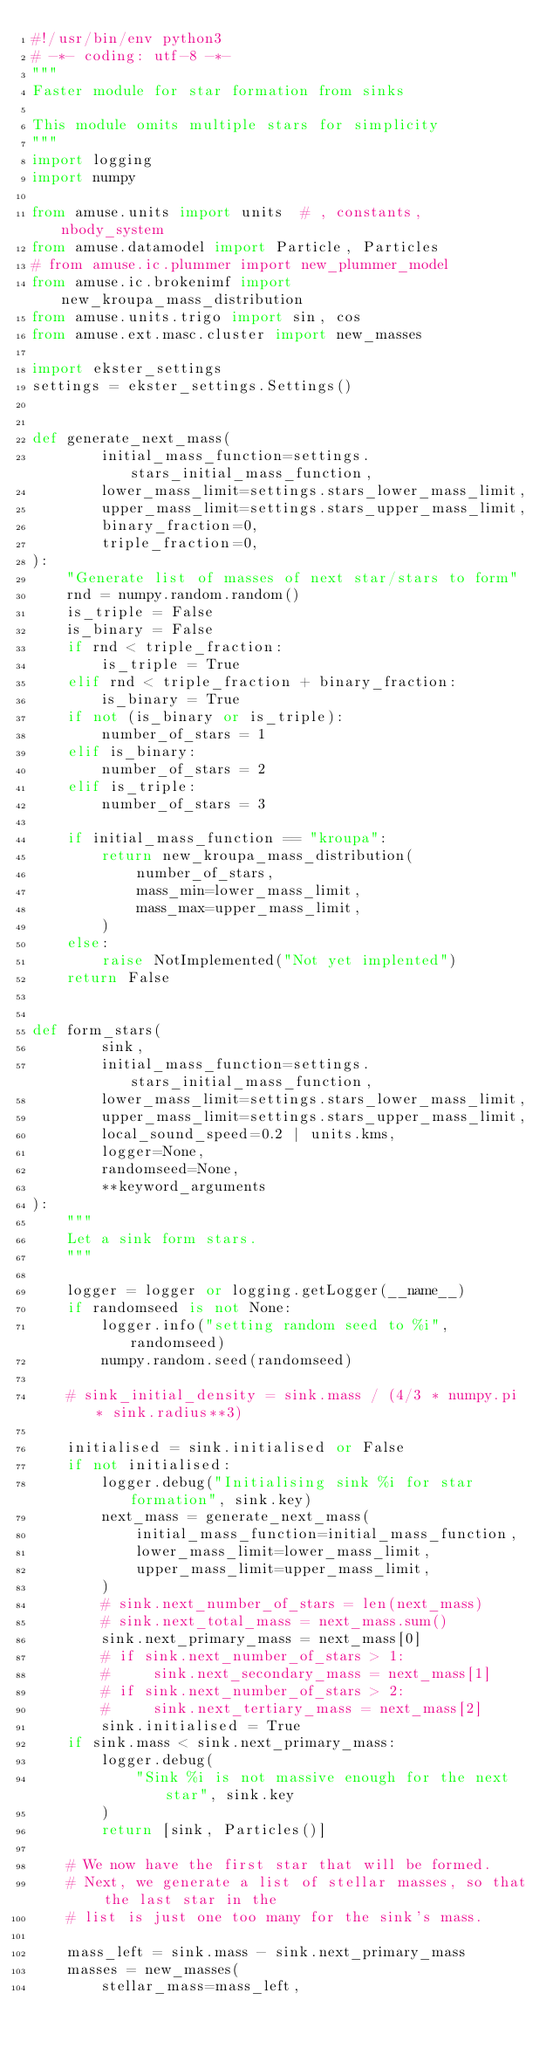<code> <loc_0><loc_0><loc_500><loc_500><_Python_>#!/usr/bin/env python3
# -*- coding: utf-8 -*-
"""
Faster module for star formation from sinks

This module omits multiple stars for simplicity
"""
import logging
import numpy

from amuse.units import units  # , constants, nbody_system
from amuse.datamodel import Particle, Particles
# from amuse.ic.plummer import new_plummer_model
from amuse.ic.brokenimf import new_kroupa_mass_distribution
from amuse.units.trigo import sin, cos
from amuse.ext.masc.cluster import new_masses

import ekster_settings
settings = ekster_settings.Settings()


def generate_next_mass(
        initial_mass_function=settings.stars_initial_mass_function,
        lower_mass_limit=settings.stars_lower_mass_limit,
        upper_mass_limit=settings.stars_upper_mass_limit,
        binary_fraction=0,
        triple_fraction=0,
):
    "Generate list of masses of next star/stars to form"
    rnd = numpy.random.random()
    is_triple = False
    is_binary = False
    if rnd < triple_fraction:
        is_triple = True
    elif rnd < triple_fraction + binary_fraction:
        is_binary = True
    if not (is_binary or is_triple):
        number_of_stars = 1
    elif is_binary:
        number_of_stars = 2
    elif is_triple:
        number_of_stars = 3

    if initial_mass_function == "kroupa":
        return new_kroupa_mass_distribution(
            number_of_stars,
            mass_min=lower_mass_limit,
            mass_max=upper_mass_limit,
        )
    else:
        raise NotImplemented("Not yet implented")
    return False


def form_stars(
        sink,
        initial_mass_function=settings.stars_initial_mass_function,
        lower_mass_limit=settings.stars_lower_mass_limit,
        upper_mass_limit=settings.stars_upper_mass_limit,
        local_sound_speed=0.2 | units.kms,
        logger=None,
        randomseed=None,
        **keyword_arguments
):
    """
    Let a sink form stars.
    """

    logger = logger or logging.getLogger(__name__)
    if randomseed is not None:
        logger.info("setting random seed to %i", randomseed)
        numpy.random.seed(randomseed)

    # sink_initial_density = sink.mass / (4/3 * numpy.pi * sink.radius**3)

    initialised = sink.initialised or False
    if not initialised:
        logger.debug("Initialising sink %i for star formation", sink.key)
        next_mass = generate_next_mass(
            initial_mass_function=initial_mass_function,
            lower_mass_limit=lower_mass_limit,
            upper_mass_limit=upper_mass_limit,
        )
        # sink.next_number_of_stars = len(next_mass)
        # sink.next_total_mass = next_mass.sum()
        sink.next_primary_mass = next_mass[0]
        # if sink.next_number_of_stars > 1:
        #     sink.next_secondary_mass = next_mass[1]
        # if sink.next_number_of_stars > 2:
        #     sink.next_tertiary_mass = next_mass[2]
        sink.initialised = True
    if sink.mass < sink.next_primary_mass:
        logger.debug(
            "Sink %i is not massive enough for the next star", sink.key
        )
        return [sink, Particles()]

    # We now have the first star that will be formed.
    # Next, we generate a list of stellar masses, so that the last star in the
    # list is just one too many for the sink's mass.

    mass_left = sink.mass - sink.next_primary_mass
    masses = new_masses(
        stellar_mass=mass_left,</code> 